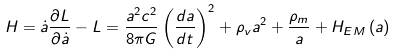<formula> <loc_0><loc_0><loc_500><loc_500>H = \dot { a } \frac { \partial L } { \partial \dot { a } } - L = \frac { a ^ { 2 } c ^ { 2 } } { 8 \pi G } \left ( { \frac { d a } { d t } } \right ) ^ { 2 } + \rho _ { v } a ^ { 2 } + \frac { \rho _ { m } } { a } + H _ { E M } \left ( a \right )</formula> 